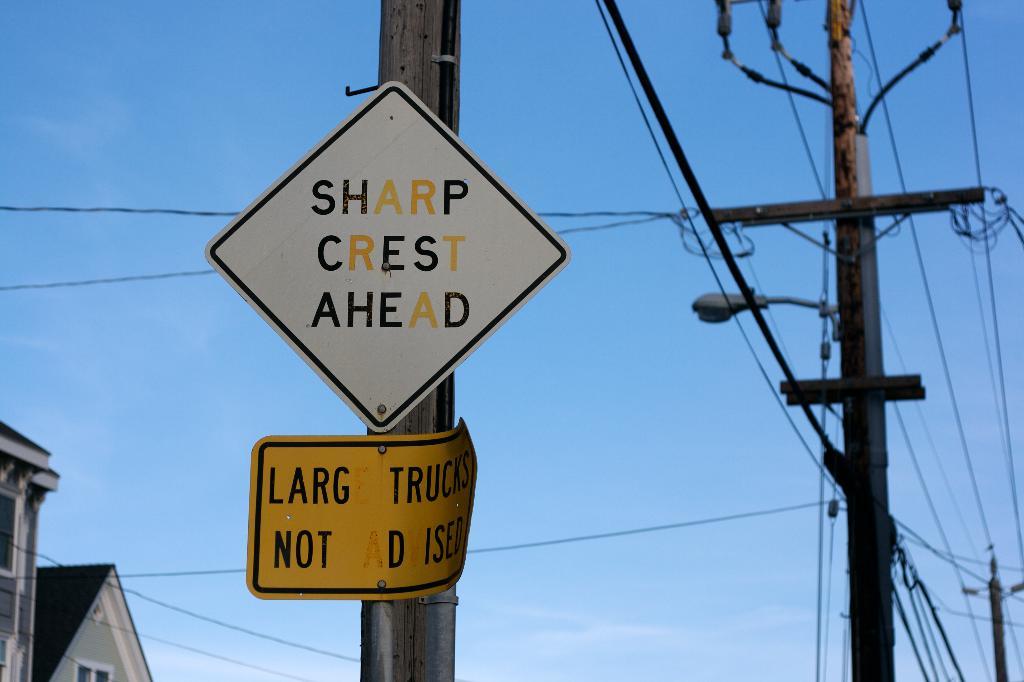What kind of crest is ahead?
Give a very brief answer. Sharp. Are there any warnings on the signs?
Make the answer very short. Yes. 